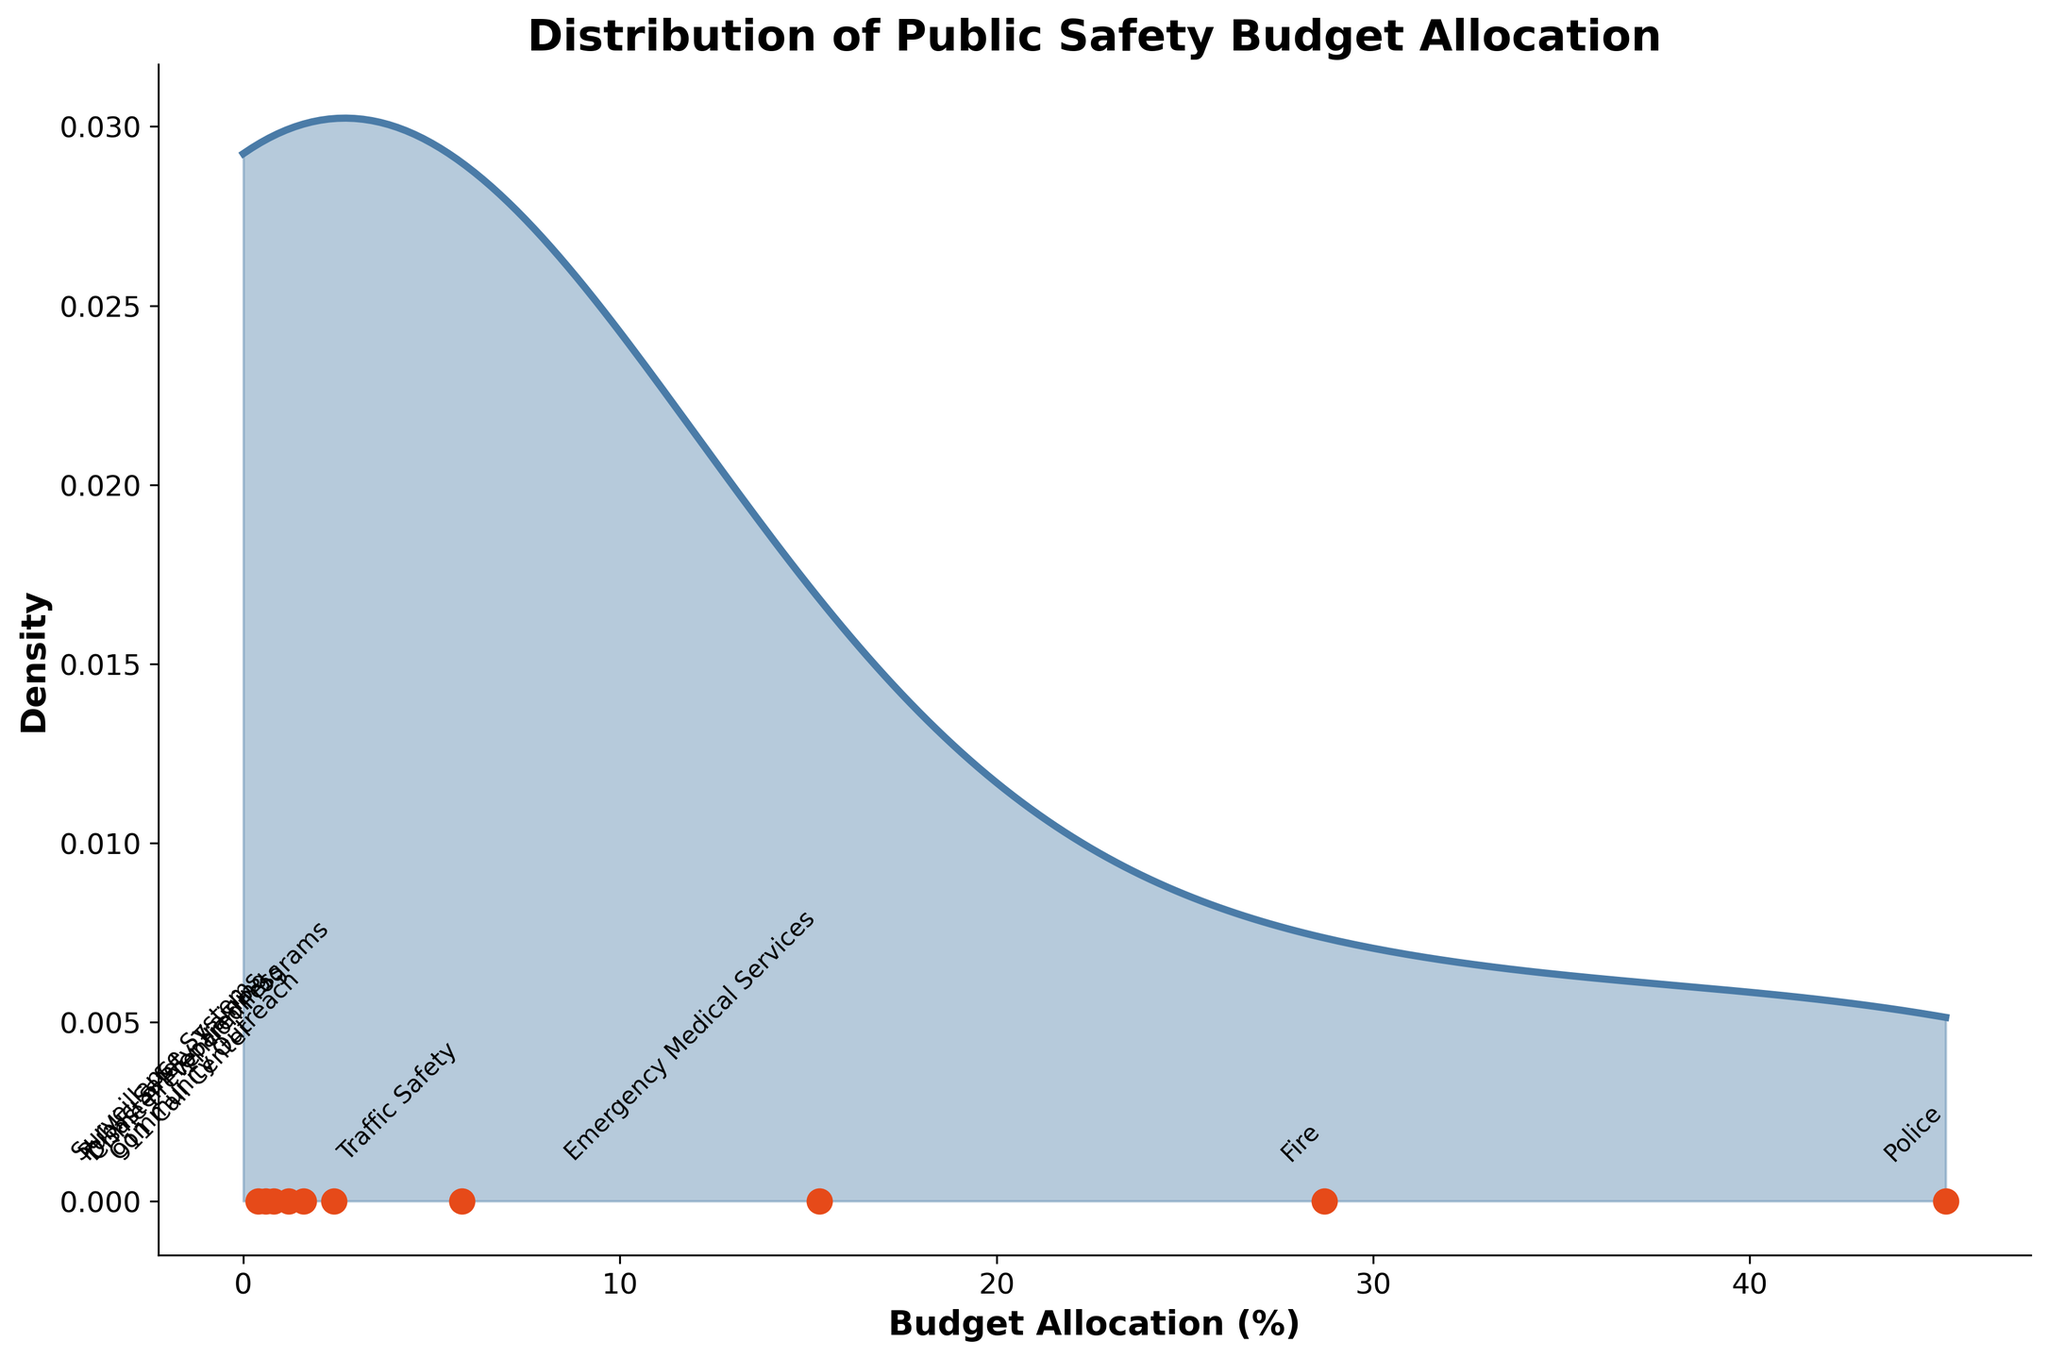How many departments are represented in the plot? The figure displays annotations for each department along the x-axis. By counting these annotations, we can find the total number of departments.
Answer: 10 What is the title of the plot? The title is typically displayed at the top of the figure in a larger, bold font.
Answer: Distribution of Public Safety Budget Allocation Which department has the highest budget allocation? To find the department with the highest budget allocation, we can look for the label that corresponds with the highest value on the x-axis.
Answer: Police What percentage of the total budget is allocated to the Police and Fire departments combined? Identify the budget allocations for both the Police (45.2%) and Fire (28.7%) departments, then sum these percentages: 45.2 + 28.7 = 73.9.
Answer: 73.9% How does the budget allocation for Crime Prevention Programs compare to that for Traffic Safety? Compare the budget allocation values of Crime Prevention Programs (2.4%) and Traffic Safety (5.8%). Crime Prevention Programs has a lower allocation.
Answer: Lower What is the range of budget allocation values represented in the plot? The range is determined by identifying the minimum and maximum values on the x-axis. The lowest budget allocation is 0.4% (911 Call Center) and the highest is 45.2% (Police). The range is 45.2 - 0.4 = 44.8.
Answer: 44.8% Which departments have budget allocations below 2%? Identify the departments on the x-axis with budget allocations below 2%, including Community Outreach (1.6%), Disaster Preparedness (1.2%), Public Safety Training (0.8%), Surveillance Systems (0.6%), and 911 Call Center (0.4%).
Answer: Community Outreach, Disaster Preparedness, Public Safety Training, Surveillance Systems, 911 Call Center What is the density peak (mode) of the budget allocation distribution? The peak (mode) of the density plot corresponds to the highest point on the curve. This is around the police department budget allocation, which is 45.2%.
Answer: 45.2% Is the distribution of budget allocations skewed? If so, in which direction? Analyze the shape of the density curve. The plot shows a long tail to the right, indicating right (positive) skewness.
Answer: Right What departments are closest to the average budget allocation? Calculate the mean by averaging all budget allocation values and then identify departments near this value. Mean = (45.2 + 28.7 + 15.3 + 5.8 + 2.4 + 1.6 + 1.2 + 0.8 + 0.6 + 0.4) / 10 = 10.2%. The Traffic Safety (5.8%) and EMS (15.3%) are the closest departments to the mean.
Answer: Traffic Safety, EMS 